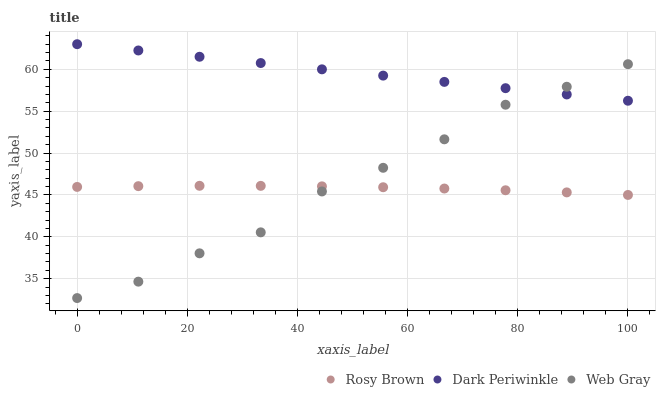Does Rosy Brown have the minimum area under the curve?
Answer yes or no. Yes. Does Dark Periwinkle have the maximum area under the curve?
Answer yes or no. Yes. Does Web Gray have the minimum area under the curve?
Answer yes or no. No. Does Web Gray have the maximum area under the curve?
Answer yes or no. No. Is Dark Periwinkle the smoothest?
Answer yes or no. Yes. Is Web Gray the roughest?
Answer yes or no. Yes. Is Web Gray the smoothest?
Answer yes or no. No. Is Dark Periwinkle the roughest?
Answer yes or no. No. Does Web Gray have the lowest value?
Answer yes or no. Yes. Does Dark Periwinkle have the lowest value?
Answer yes or no. No. Does Dark Periwinkle have the highest value?
Answer yes or no. Yes. Does Web Gray have the highest value?
Answer yes or no. No. Is Rosy Brown less than Dark Periwinkle?
Answer yes or no. Yes. Is Dark Periwinkle greater than Rosy Brown?
Answer yes or no. Yes. Does Web Gray intersect Rosy Brown?
Answer yes or no. Yes. Is Web Gray less than Rosy Brown?
Answer yes or no. No. Is Web Gray greater than Rosy Brown?
Answer yes or no. No. Does Rosy Brown intersect Dark Periwinkle?
Answer yes or no. No. 